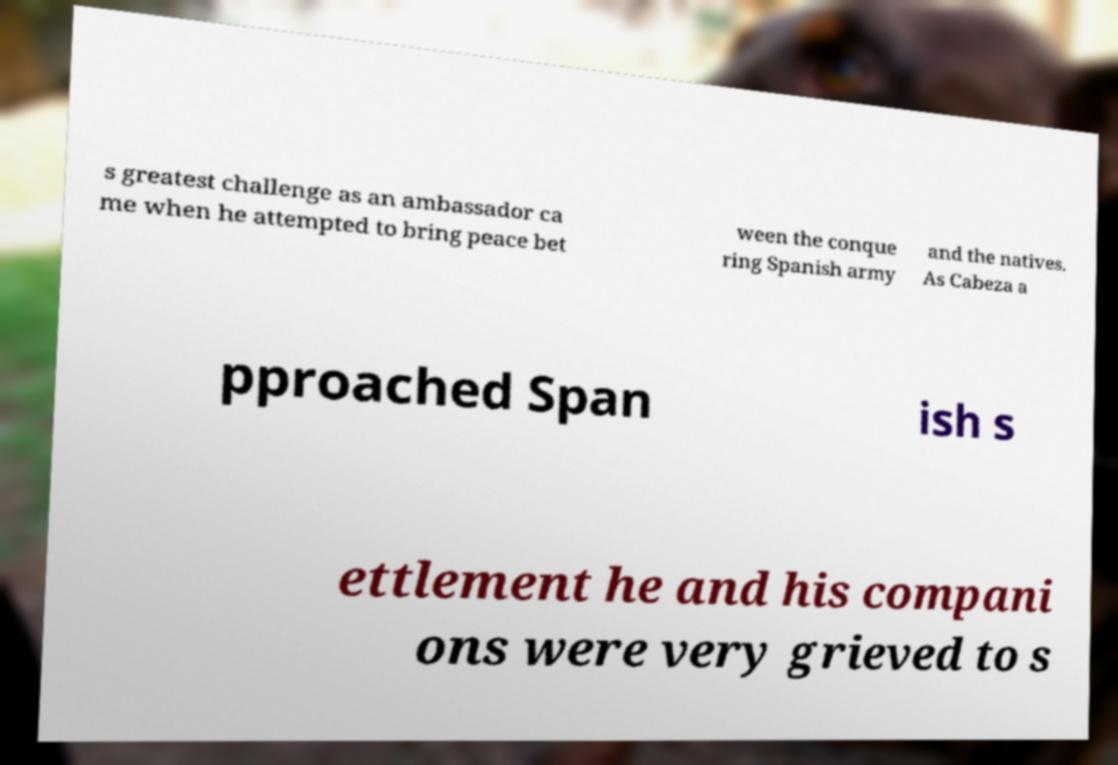Can you accurately transcribe the text from the provided image for me? s greatest challenge as an ambassador ca me when he attempted to bring peace bet ween the conque ring Spanish army and the natives. As Cabeza a pproached Span ish s ettlement he and his compani ons were very grieved to s 